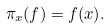Convert formula to latex. <formula><loc_0><loc_0><loc_500><loc_500>\pi _ { x } ( f ) = f ( x ) .</formula> 